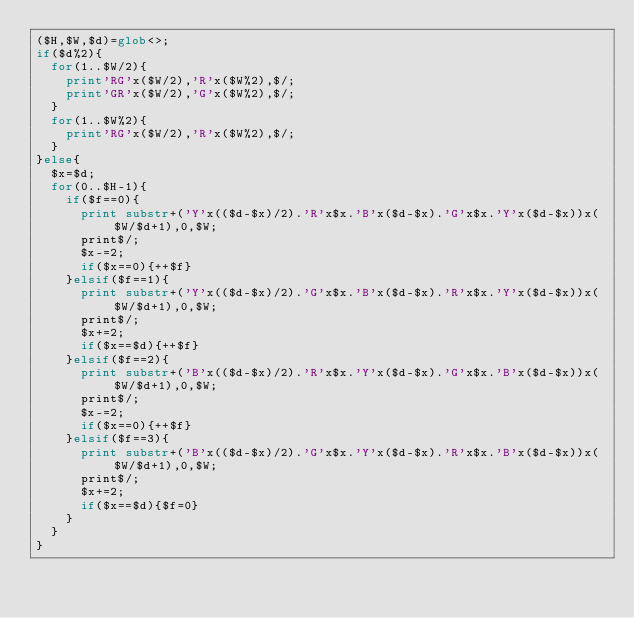<code> <loc_0><loc_0><loc_500><loc_500><_Perl_>($H,$W,$d)=glob<>;
if($d%2){
	for(1..$W/2){
		print'RG'x($W/2),'R'x($W%2),$/;
		print'GR'x($W/2),'G'x($W%2),$/;
	}
	for(1..$W%2){
		print'RG'x($W/2),'R'x($W%2),$/;
	}
}else{
	$x=$d;
	for(0..$H-1){
		if($f==0){
			print substr+('Y'x(($d-$x)/2).'R'x$x.'B'x($d-$x).'G'x$x.'Y'x($d-$x))x($W/$d+1),0,$W;
			print$/;
			$x-=2;
			if($x==0){++$f}
		}elsif($f==1){
			print substr+('Y'x(($d-$x)/2).'G'x$x.'B'x($d-$x).'R'x$x.'Y'x($d-$x))x($W/$d+1),0,$W;
			print$/;
			$x+=2;
			if($x==$d){++$f}
		}elsif($f==2){
			print substr+('B'x(($d-$x)/2).'R'x$x.'Y'x($d-$x).'G'x$x.'B'x($d-$x))x($W/$d+1),0,$W;
			print$/;
			$x-=2;
			if($x==0){++$f}
		}elsif($f==3){
			print substr+('B'x(($d-$x)/2).'G'x$x.'Y'x($d-$x).'R'x$x.'B'x($d-$x))x($W/$d+1),0,$W;
			print$/;
			$x+=2;
			if($x==$d){$f=0}
		}
	}
}
</code> 